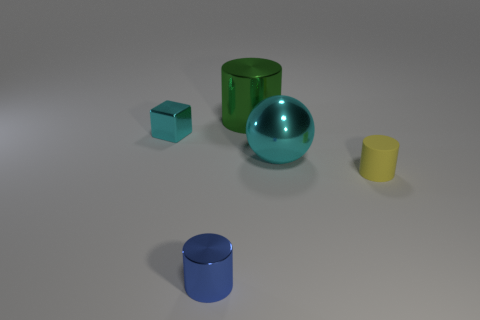Subtract all tiny cylinders. How many cylinders are left? 1 Subtract all yellow cylinders. How many cylinders are left? 2 Add 4 large green cylinders. How many objects exist? 9 Subtract 1 cubes. How many cubes are left? 0 Subtract all cubes. How many objects are left? 4 Subtract all yellow cylinders. How many purple blocks are left? 0 Add 3 large yellow matte objects. How many large yellow matte objects exist? 3 Subtract 0 gray blocks. How many objects are left? 5 Subtract all blue spheres. Subtract all red blocks. How many spheres are left? 1 Subtract all cyan shiny balls. Subtract all metallic cylinders. How many objects are left? 2 